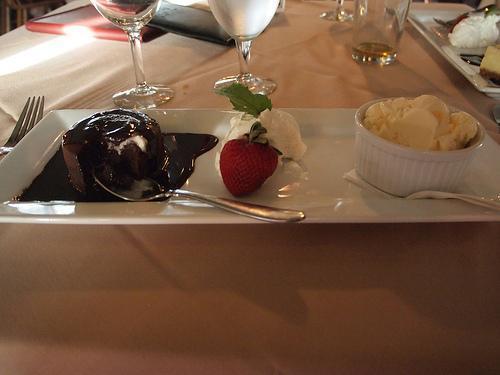How many different items are on the plate?
Give a very brief answer. 3. How many settings can you see?
Give a very brief answer. 2. How many glasses are in the picture?
Give a very brief answer. 4. 